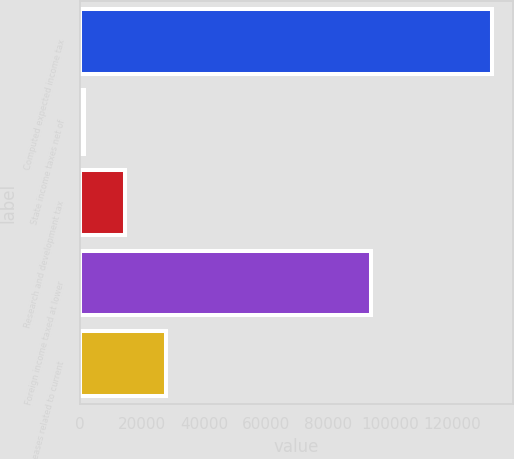Convert chart. <chart><loc_0><loc_0><loc_500><loc_500><bar_chart><fcel>Computed expected income tax<fcel>State income taxes net of<fcel>Research and development tax<fcel>Foreign income taxed at lower<fcel>Increases related to current<nl><fcel>132894<fcel>1280<fcel>14441.4<fcel>93905<fcel>27602.8<nl></chart> 